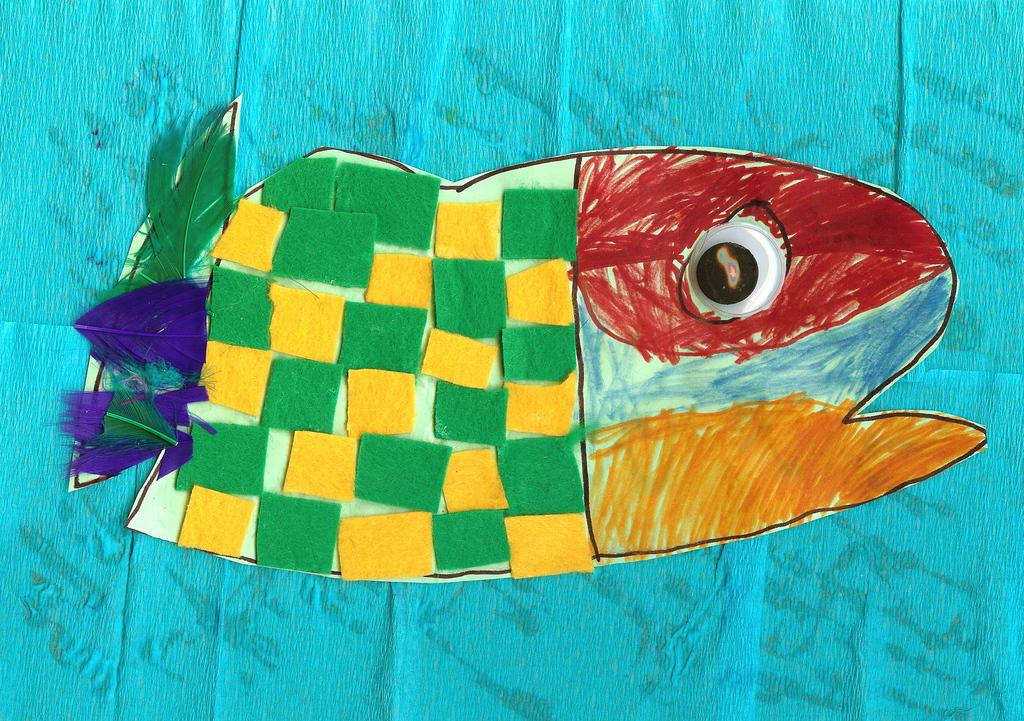What is depicted in the paper art in the image? There is a paper art of a fish in the image. What is the paper art placed on in the image? The paper art is on an object. What type of zephyr can be seen flying in the image? There is no zephyr present in the image. Can you tell me how close the coast is to the paper art in the image? The image does not provide any information about the proximity of a coast. 